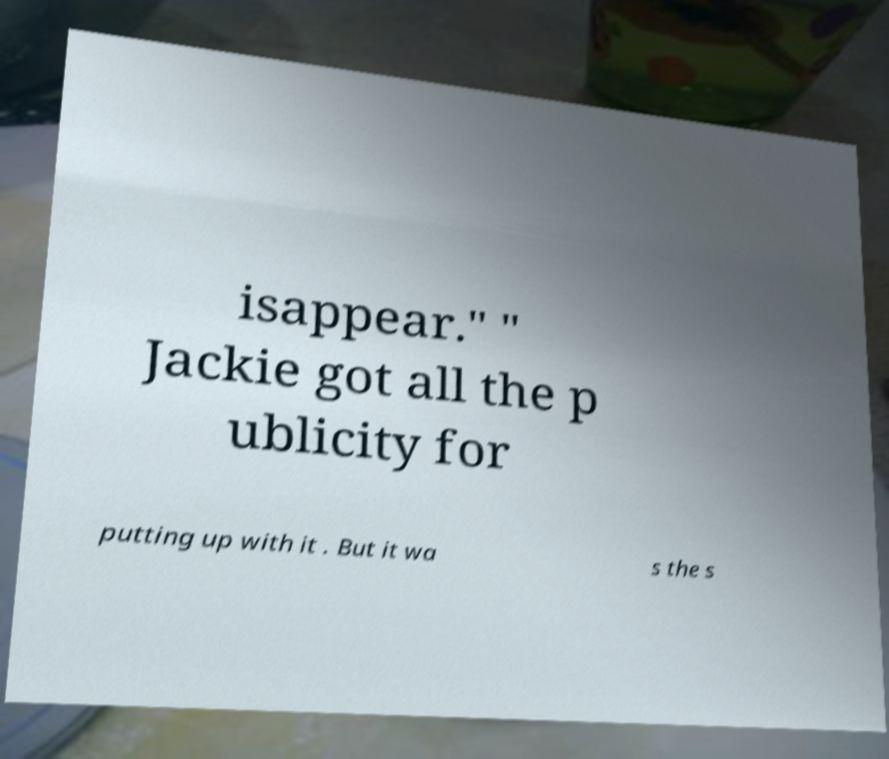Can you accurately transcribe the text from the provided image for me? isappear." " Jackie got all the p ublicity for putting up with it . But it wa s the s 